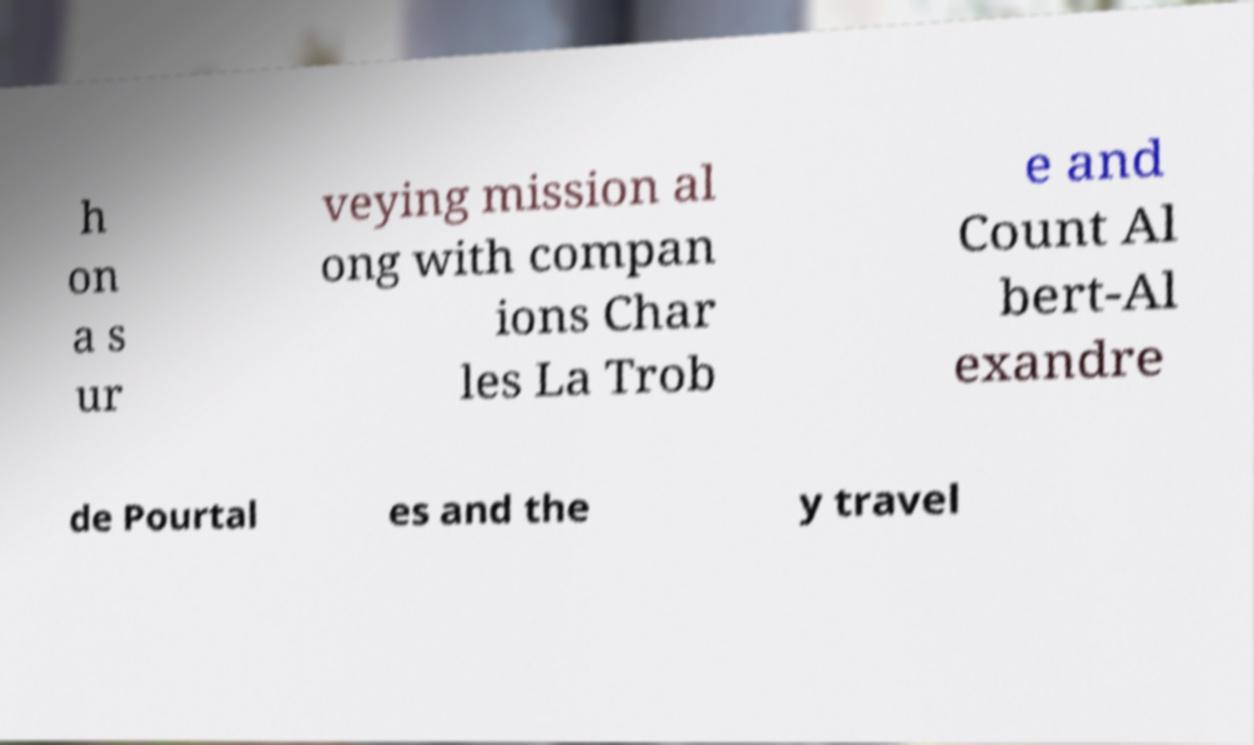There's text embedded in this image that I need extracted. Can you transcribe it verbatim? h on a s ur veying mission al ong with compan ions Char les La Trob e and Count Al bert-Al exandre de Pourtal es and the y travel 